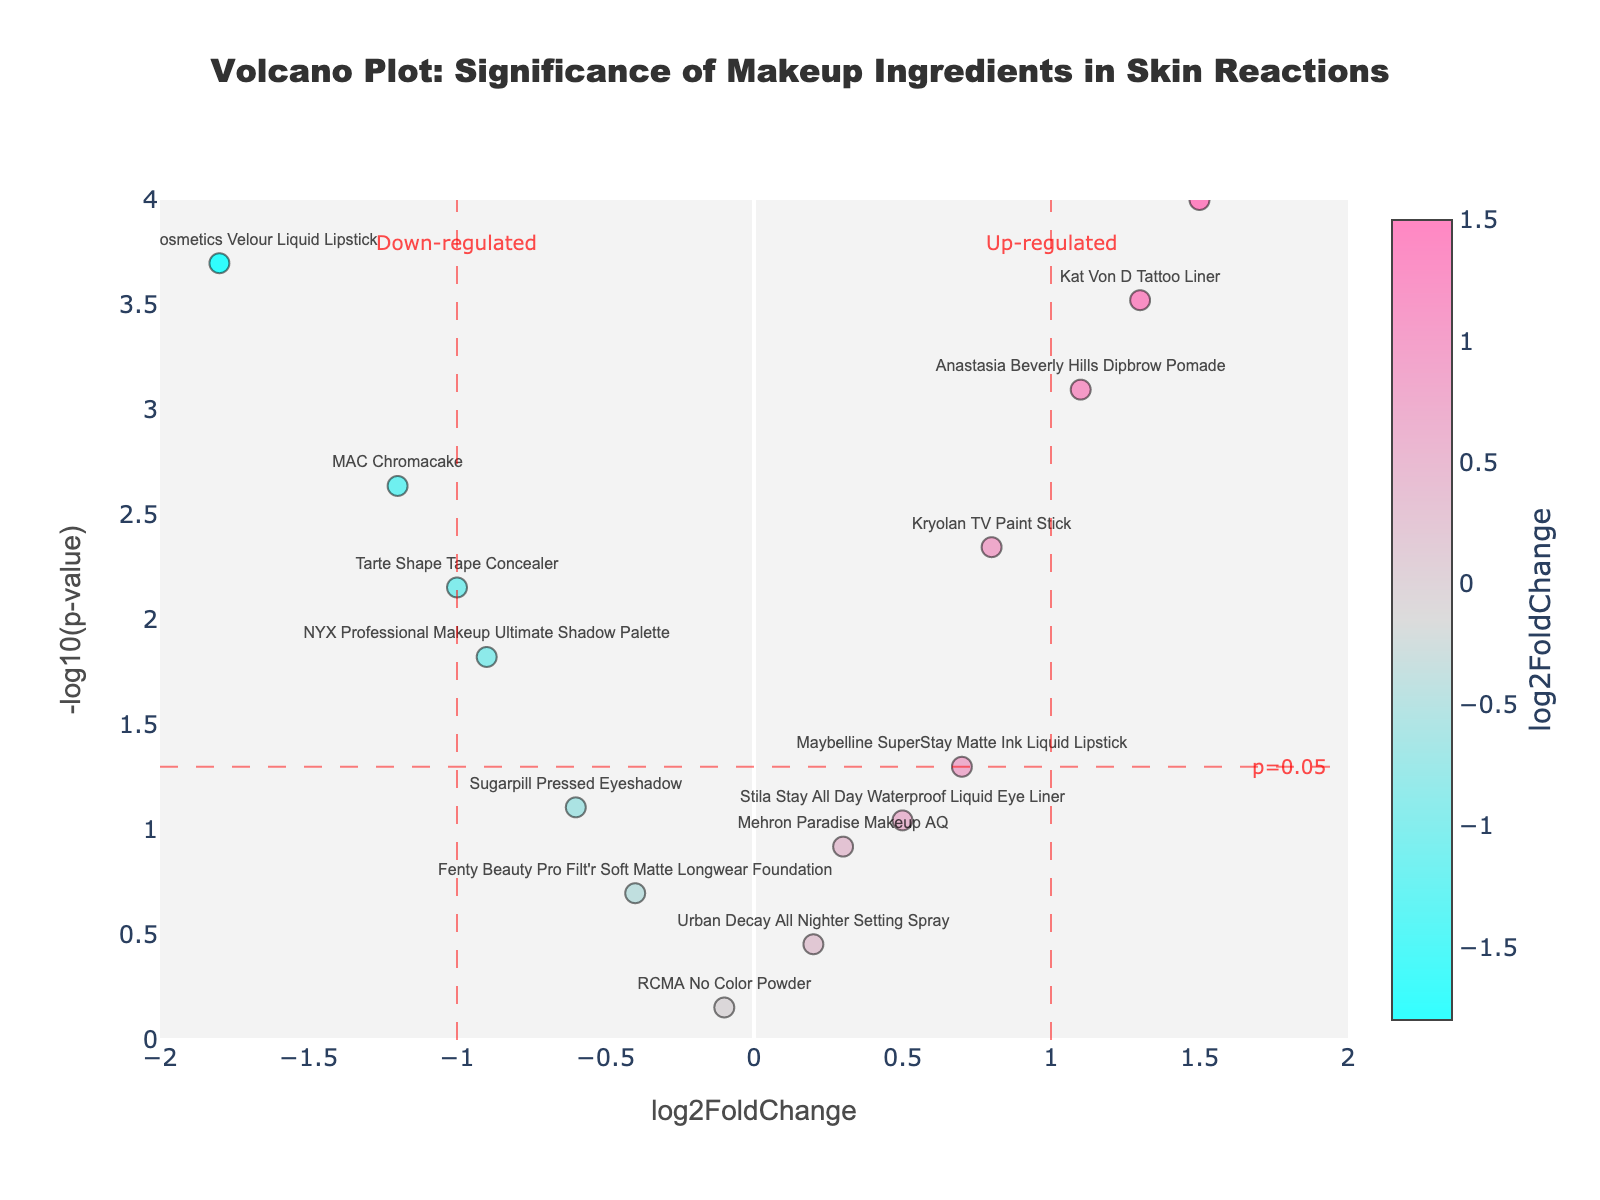Which ingredients are the most significant in causing skin reactions? Look for data points with the highest values on the y-axis (i.e., -log10(p-value) > 2) and log2FoldChange above or below the threshold of 1. Example: 'Ben Nye Creme Color', 'Anastasia Beverly Hills Dipbrow Pomade', 'Kat Von D Tattoo Liner', and 'Jeffree Star Cosmetics Velour Liquid Lipstick' are very significant.
Answer: Ben Nye Creme Color, Anastasia Beverly Hills Dipbrow Pomade, Kat Von D Tattoo Liner, Jeffree Star Cosmetics Velour Liquid Lipstick Which ingredient has the highest log2FoldChange among all those with a p-value less than 0.05? Identify the data point with the maximum log2FoldChange value (y-axis: -log10(p-value) > 1.301) and note its corresponding ingredient. 'Ben Nye Creme Color' has the highest log2FoldChange value among significant data points.
Answer: Ben Nye Creme Color What is the significance threshold p-value displayed in the plot? Note the annotation next to the horizontal threshold line. The threshold line is labeled as "p=0.05."
Answer: p=0.05 How many ingredients are classified as up-regulated with significant p-values? Count the data points with log2FoldChange > 1 and -log10(p-value) > 1.301. 'Ben Nye Creme Color', 'Anastasia Beverly Hills Dipbrow Pomade', 'Kat Von D Tattoo Liner' all meet this criterion.
Answer: 3 Does 'MAC Chromacake' have a significant impact on causing skin reactions? Check if 'MAC Chromacake' falls above the p-value threshold line (y-axis: -log10(pValue) > 1.301). It doesn't meet the threshold significance.
Answer: No Which ingredient is down-regulated but significant in causing skin reactions? Identify data points with log2FoldChange < -1 and -log10(p-value) > 1.301. 'Jeffree Star Cosmetics Velour Liquid Lipstick' is down-regulated and significant.
Answer: Jeffree Star Cosmetics Velour Liquid Lipstick Are any ingredients non-significant since they fall below the threshold line? Look for data points below the horizontal threshold line of -log10(p-value) < 1.301. Examples include 'Urban Decay All Nighter Setting Spray', 'Fenty Beauty Pro Filt'r Soft Matte Longwear Foundation', and 'Mehron Paradise Makeup AQ'.
Answer: Yes Between 'Kryolan TV Paint Stick' and 'Tarte Shape Tape Concealer,' which one is more significant? Compare their y-axis values (-log10(p-value)). 'Tarte Shape Tape Concealer' has a higher y-axis value than 'Kryolan TV Paint Stick'.
Answer: Tarte Shape Tape Concealer 